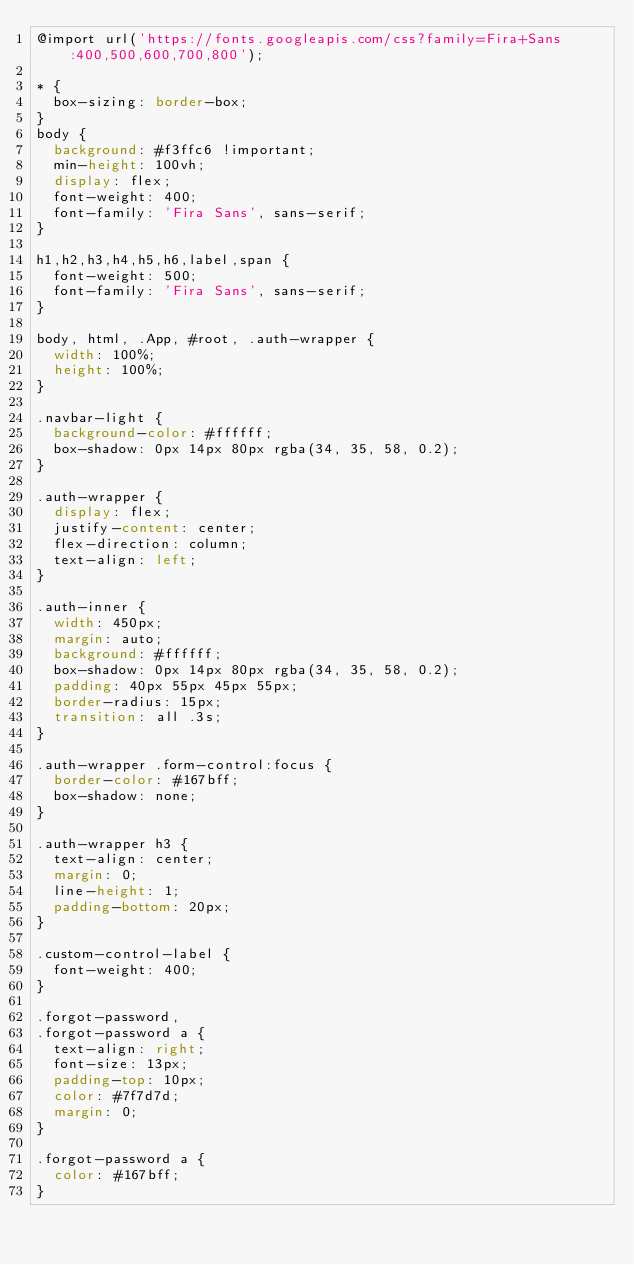<code> <loc_0><loc_0><loc_500><loc_500><_CSS_>@import url('https://fonts.googleapis.com/css?family=Fira+Sans:400,500,600,700,800');

* {
  box-sizing: border-box;
}
body {
  background: #f3ffc6 !important;
  min-height: 100vh;
  display: flex;
  font-weight: 400;
  font-family: 'Fira Sans', sans-serif;
}

h1,h2,h3,h4,h5,h6,label,span {
  font-weight: 500;
  font-family: 'Fira Sans', sans-serif;
}

body, html, .App, #root, .auth-wrapper {
  width: 100%;
  height: 100%;
}

.navbar-light {
  background-color: #ffffff;
  box-shadow: 0px 14px 80px rgba(34, 35, 58, 0.2);
}

.auth-wrapper {
  display: flex;
  justify-content: center;
  flex-direction: column;
  text-align: left;
}

.auth-inner {
  width: 450px;
  margin: auto;
  background: #ffffff;
  box-shadow: 0px 14px 80px rgba(34, 35, 58, 0.2);
  padding: 40px 55px 45px 55px;
  border-radius: 15px;
  transition: all .3s;
}

.auth-wrapper .form-control:focus {
  border-color: #167bff;
  box-shadow: none;
}

.auth-wrapper h3 {
  text-align: center;
  margin: 0;
  line-height: 1;
  padding-bottom: 20px;
}

.custom-control-label {
  font-weight: 400;
}

.forgot-password,
.forgot-password a {
  text-align: right;
  font-size: 13px;
  padding-top: 10px;
  color: #7f7d7d;
  margin: 0;
}

.forgot-password a {
  color: #167bff;
}</code> 